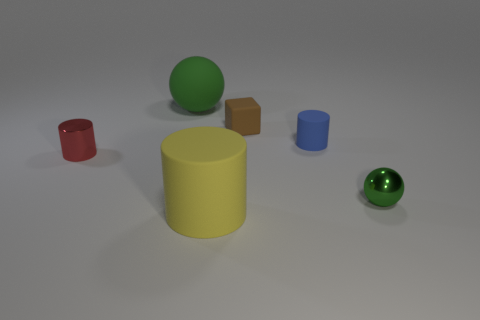How many other things are the same shape as the brown thing?
Offer a very short reply. 0. There is a matte object that is in front of the tiny red cylinder that is in front of the matte cylinder that is behind the big yellow object; what is its size?
Offer a very short reply. Large. What number of brown objects are small matte objects or small things?
Your response must be concise. 1. What shape is the tiny metal object that is behind the shiny object to the right of the tiny brown rubber thing?
Give a very brief answer. Cylinder. There is a green thing that is in front of the brown cube; is its size the same as the matte cylinder that is in front of the small blue cylinder?
Your answer should be compact. No. Is there a small thing made of the same material as the large cylinder?
Your answer should be very brief. Yes. There is another sphere that is the same color as the large matte sphere; what is its size?
Ensure brevity in your answer.  Small. Are there any small red metallic things that are to the right of the metallic object that is right of the matte thing that is on the right side of the tiny brown block?
Make the answer very short. No. Are there any small metallic objects behind the big sphere?
Provide a short and direct response. No. There is a tiny cylinder that is on the left side of the small blue object; what number of large matte things are in front of it?
Your answer should be very brief. 1. 